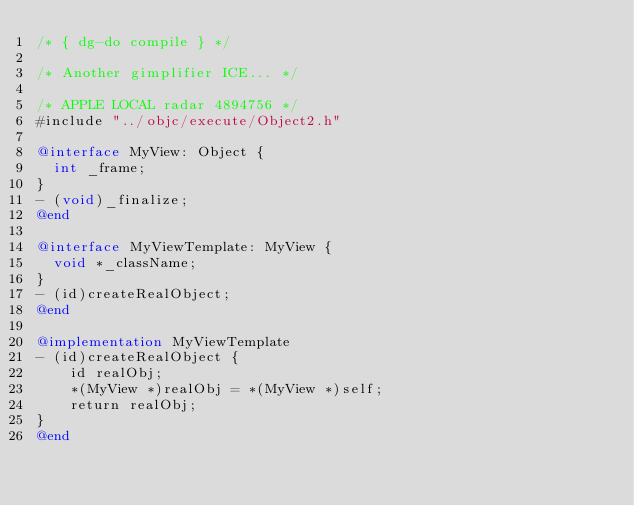Convert code to text. <code><loc_0><loc_0><loc_500><loc_500><_ObjectiveC_>/* { dg-do compile } */

/* Another gimplifier ICE... */

/* APPLE LOCAL radar 4894756 */
#include "../objc/execute/Object2.h"

@interface MyView: Object {
  int _frame;
}
- (void)_finalize;
@end

@interface MyViewTemplate: MyView {
  void *_className;
}
- (id)createRealObject;
@end

@implementation MyViewTemplate
- (id)createRealObject {
    id realObj;
    *(MyView *)realObj = *(MyView *)self;
    return realObj;
}
@end
</code> 